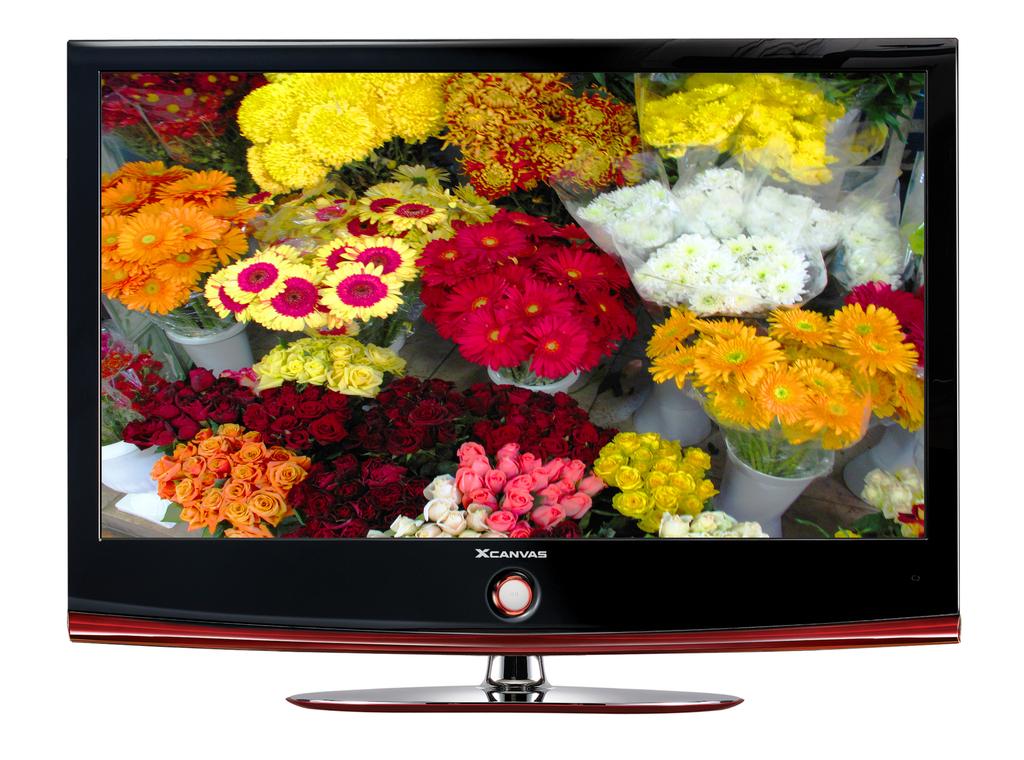What brand is this television?
Provide a succinct answer. Xcanvas. 